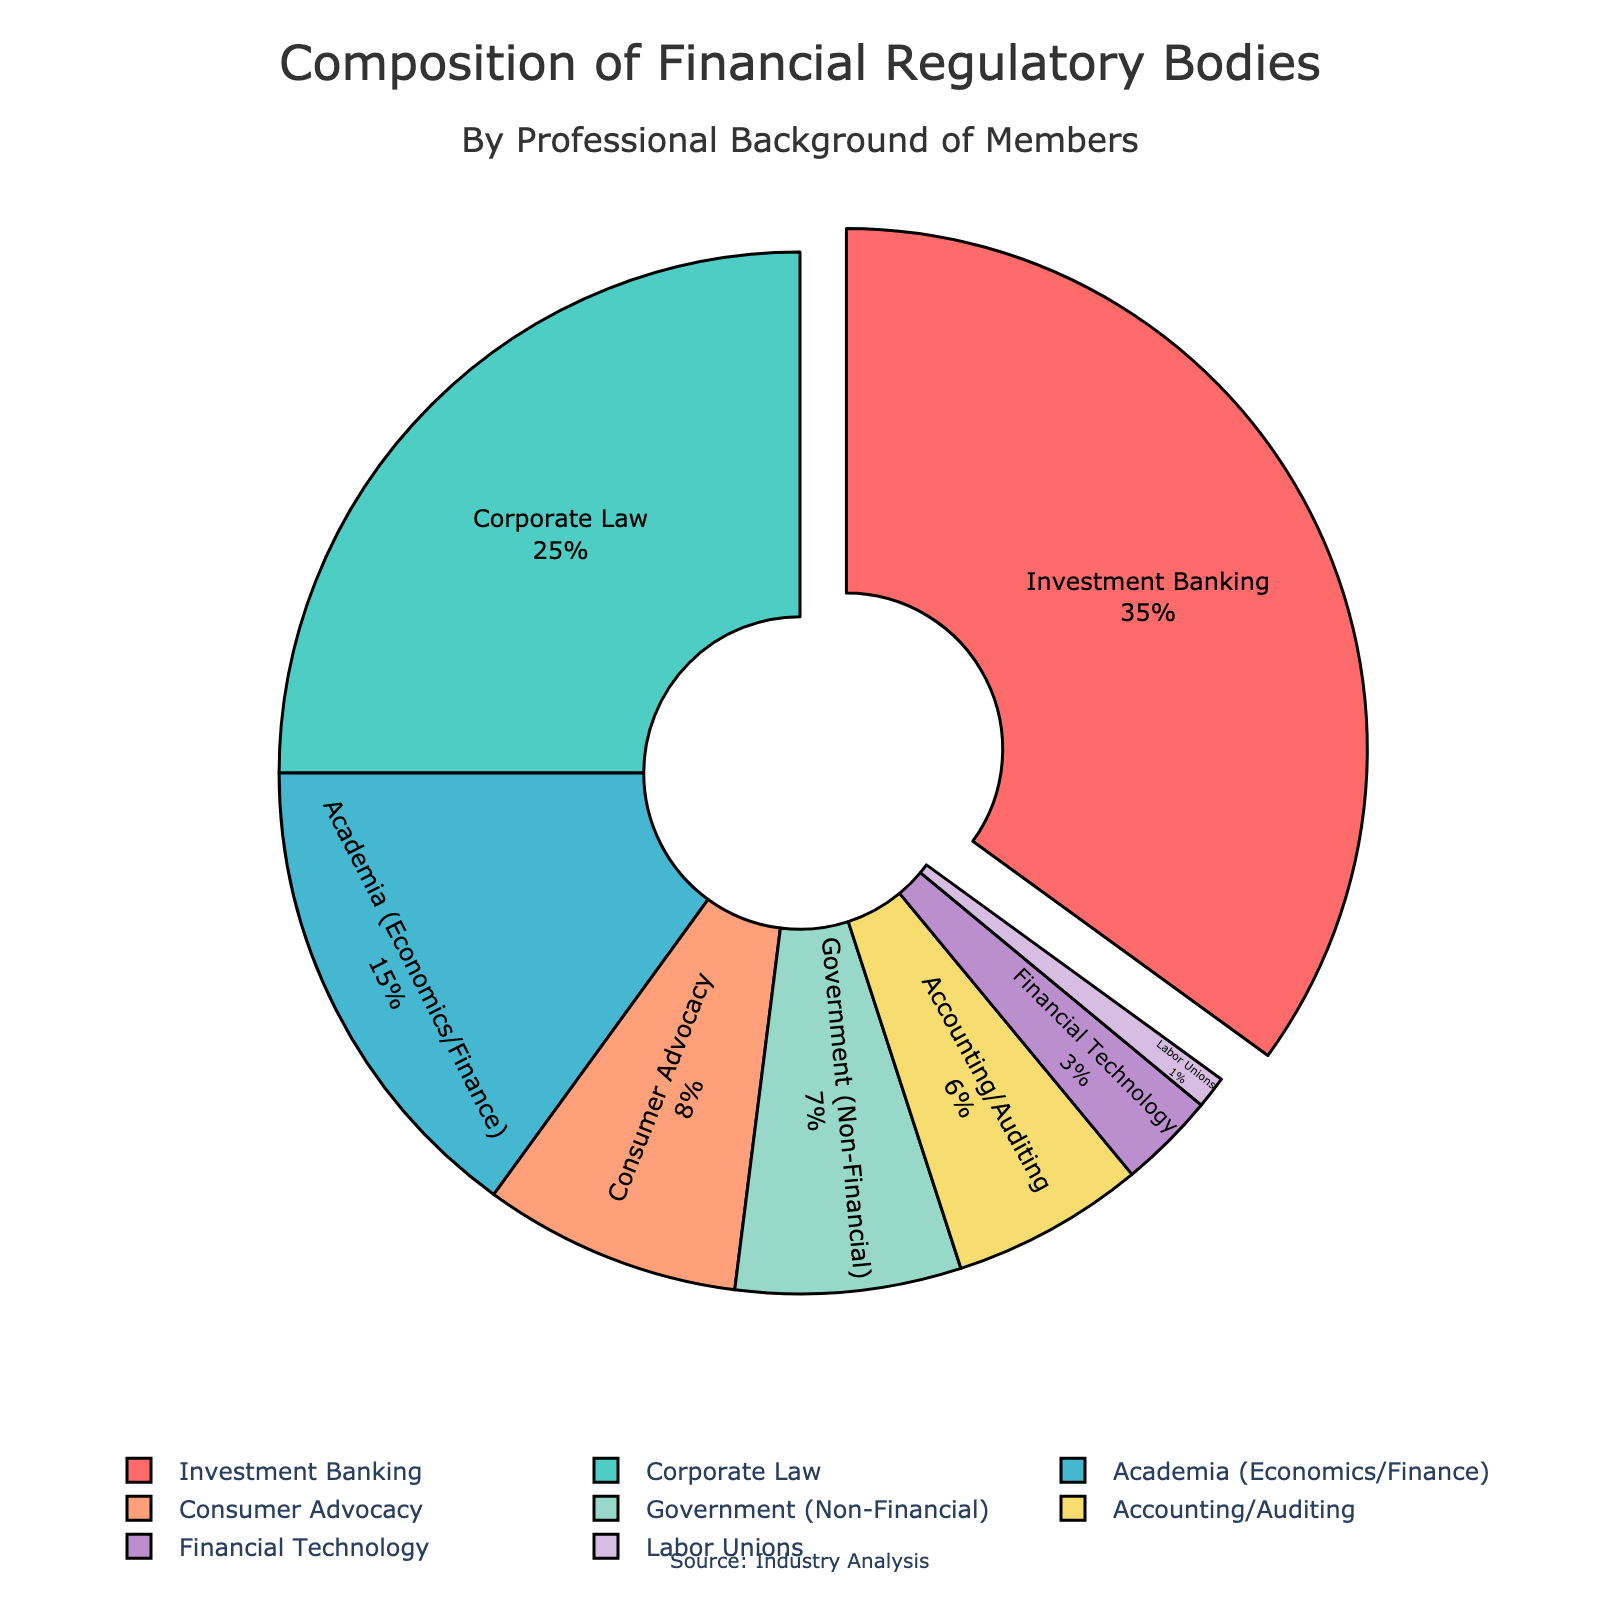Which professional background has the largest representation in the regulatory bodies? The figure shows percentages for each professional background. Investment Banking has the largest slice, indicating it has the largest representation at 35%.
Answer: Investment Banking Compare the representation of Academia (Economics/Finance) to Consumer Advocacy. Which is larger? The pie chart indicates that Academia (Economics/Finance) has 15% representation, while Consumer Advocacy has 8%. Therefore, Academia (Economics/Finance) has a larger representation.
Answer: Academia (Economics/Finance) What is the combined percentage of members from Corporate Law and Accounting/Auditing? The figure shows Corporate Law at 25% and Accounting/Auditing at 6%. Adding these values gives 25% + 6% = 31%.
Answer: 31% How much more representation does Investment Banking have compared to Labor Unions? Investment Banking has 35% representation, and Labor Unions have 1%. The difference is 35% - 1% = 34%.
Answer: 34% What is the combined representation of Government (Non-Financial) and Financial Technology? Government (Non-Financial) is at 7%, and Financial Technology is at 3%. Adding these values gives 7% + 3% = 10%.
Answer: 10% Which professional background has the smallest representation? The smallest slice in the pie chart corresponds to Labor Unions, indicating it has the smallest representation at 1%.
Answer: Labor Unions How does the slice for Consumer Advocacy compare visually to that of Accountancy/Auditing? The pie chart shows Consumer Advocacy at 8% and Accounting/Auditing at 6%. The slice for Consumer Advocacy is slightly larger visually than that for Accounting/Auditing.
Answer: Consumer Advocacy is larger What is the total percentage of members from backgrounds other than Investment Banking and Corporate Law? Subtracting the percentages for Investment Banking (35%) and Corporate Law (25%) from 100% gives 100% - 35% - 25% = 40%.
Answer: 40% Which two professional backgrounds together constitute nearly half of the regulatory body membership? Investment Banking (35%) and Corporate Law (25%) together constitute 35% + 25% = 60%, which is more than half. This matches the prompt requirements.
Answer: Investment Banking and Corporate Law 